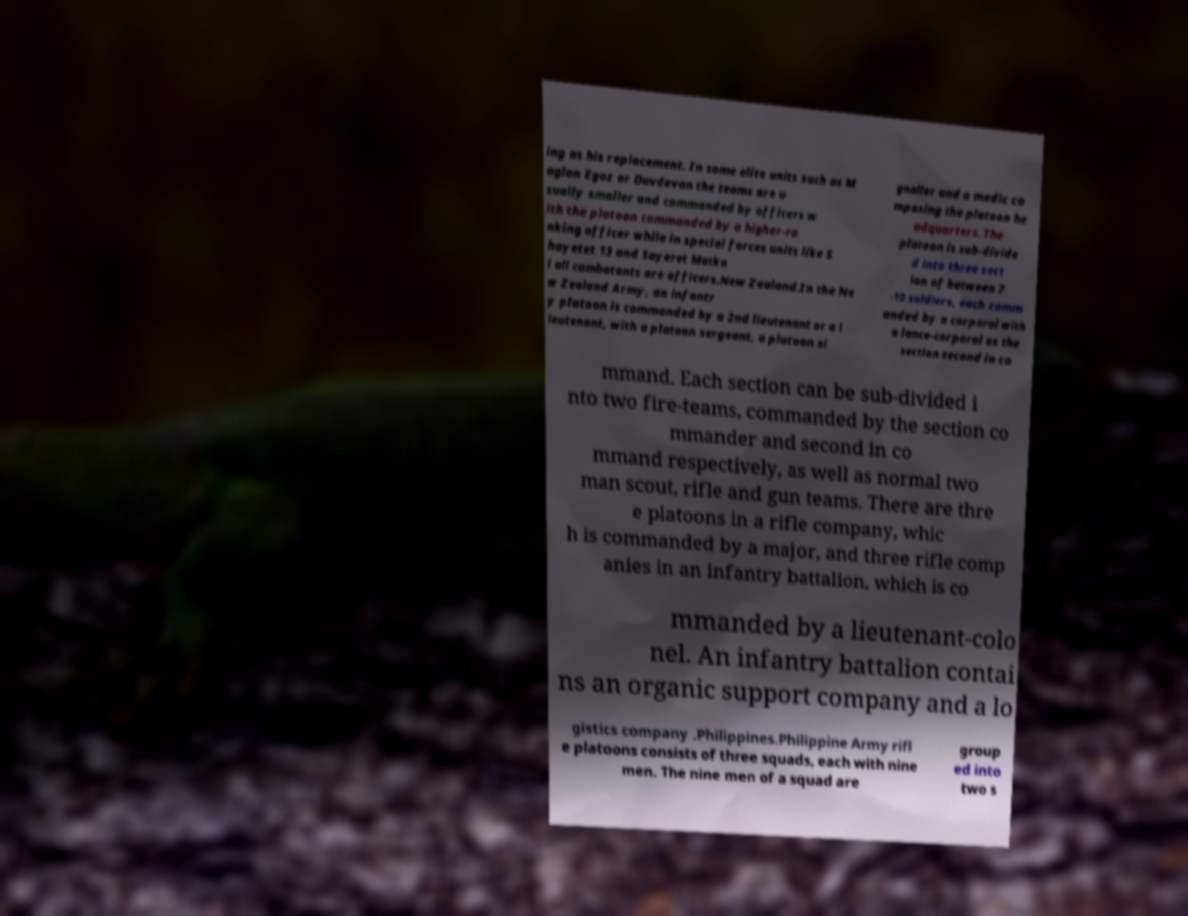Could you assist in decoding the text presented in this image and type it out clearly? ing as his replacement. In some elite units such as M aglan Egoz or Duvdevan the teams are u sually smaller and commanded by officers w ith the platoon commanded by a higher-ra nking officer while in special forces units like S hayetet 13 and Sayeret Matka l all combatants are officers.New Zealand.In the Ne w Zealand Army, an infantr y platoon is commanded by a 2nd lieutenant or a l ieutenant, with a platoon sergeant, a platoon si gnaller and a medic co mposing the platoon he adquarters. The platoon is sub-divide d into three sect ion of between 7 -10 soldiers, each comm anded by a corporal with a lance-corporal as the section second in co mmand. Each section can be sub-divided i nto two fire-teams, commanded by the section co mmander and second in co mmand respectively, as well as normal two man scout, rifle and gun teams. There are thre e platoons in a rifle company, whic h is commanded by a major, and three rifle comp anies in an infantry battalion, which is co mmanded by a lieutenant-colo nel. An infantry battalion contai ns an organic support company and a lo gistics company .Philippines.Philippine Army rifl e platoons consists of three squads, each with nine men. The nine men of a squad are group ed into two s 